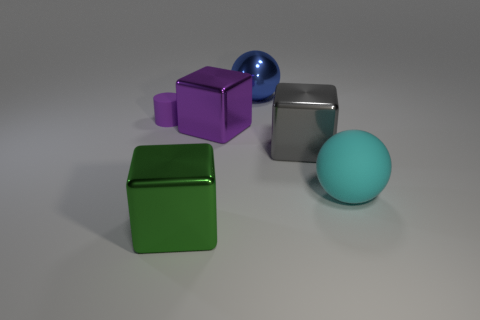Subtract all green shiny cubes. How many cubes are left? 2 Add 2 green cubes. How many objects exist? 8 Subtract all brown cubes. Subtract all yellow spheres. How many cubes are left? 3 Subtract all red metallic cylinders. Subtract all gray metallic cubes. How many objects are left? 5 Add 6 blue objects. How many blue objects are left? 7 Add 6 yellow things. How many yellow things exist? 6 Subtract 0 blue cubes. How many objects are left? 6 Subtract all balls. How many objects are left? 4 